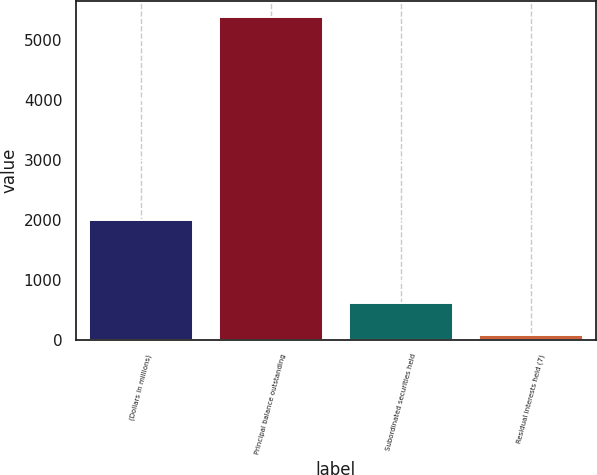Convert chart to OTSL. <chart><loc_0><loc_0><loc_500><loc_500><bar_chart><fcel>(Dollars in millions)<fcel>Principal balance outstanding<fcel>Subordinated securities held<fcel>Residual interests held (7)<nl><fcel>2008<fcel>5385<fcel>614.1<fcel>84<nl></chart> 